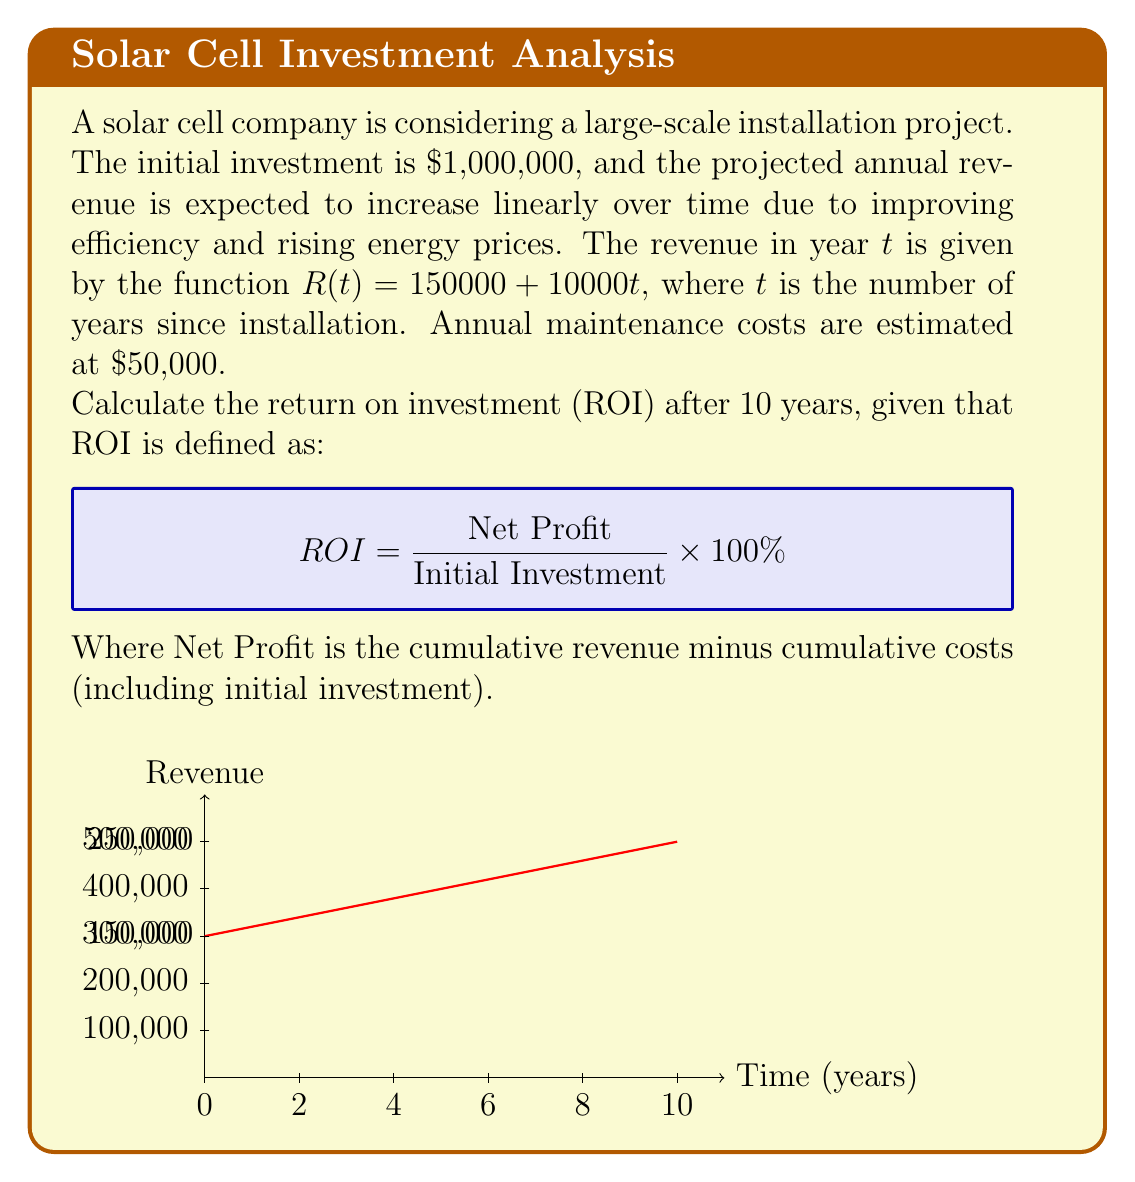Teach me how to tackle this problem. Let's approach this step-by-step:

1) First, we need to calculate the cumulative revenue over 10 years. The revenue function is given by $R(t) = 150000 + 10000t$.

2) To find the total revenue, we need to sum this function from t = 0 to t = 9 (as the first year is t = 0):

   $\text{Total Revenue} = \sum_{t=0}^{9} (150000 + 10000t)$

3) This is an arithmetic series. We can use the formula for the sum of an arithmetic series:

   $S_n = \frac{n}{2}(a_1 + a_n)$, where $a_1$ is the first term and $a_n$ is the last term.

4) In our case:
   $n = 10$
   $a_1 = 150000$
   $a_{10} = 150000 + 10000(9) = 240000$

5) Plugging into the formula:

   $\text{Total Revenue} = \frac{10}{2}(150000 + 240000) = 1,950,000$

6) Now, let's calculate the total costs:
   Initial investment: $1,000,000
   Annual maintenance: $50,000 * 10 years = $500,000
   Total costs: $1,500,000

7) Net Profit = Total Revenue - Total Costs
              = $1,950,000 - $1,500,000 = $450,000

8) Now we can calculate ROI:

   $ROI = \frac{\text{Net Profit}}{\text{Initial Investment}} \times 100\%$
        $= \frac{450000}{1000000} \times 100\% = 45\%$
Answer: 45% 